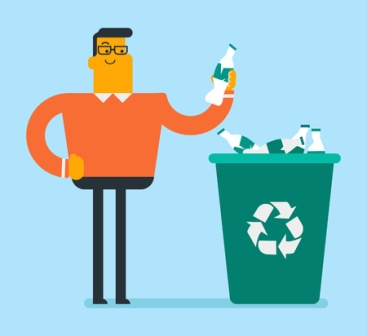Can you create a story about a day in the life of the man in this image? John wakes up each morning feeling a sense of purpose. He believes that his small actions can make a significant impact on the environment. After eating a quick breakfast, he dons his favorite orange sweater, a gift from his daughter who shares his passion for recycling. As he heads to work, he makes a quick stop by the local park to pick up any litter – John knows that every bit counts. At his office, John oversees the recycling program, ensuring that all waste is sorted correctly. His colleagues admire his dedication, often stopping by his desk for advice on how they can be more eco-friendly. In the afternoon, he participates in a community cleanup event, teaching children about the importance of recycling. The day ends with John smiling, satisfied with his efforts and hopeful for a greener future, as he recycles some bottles before heading home. 